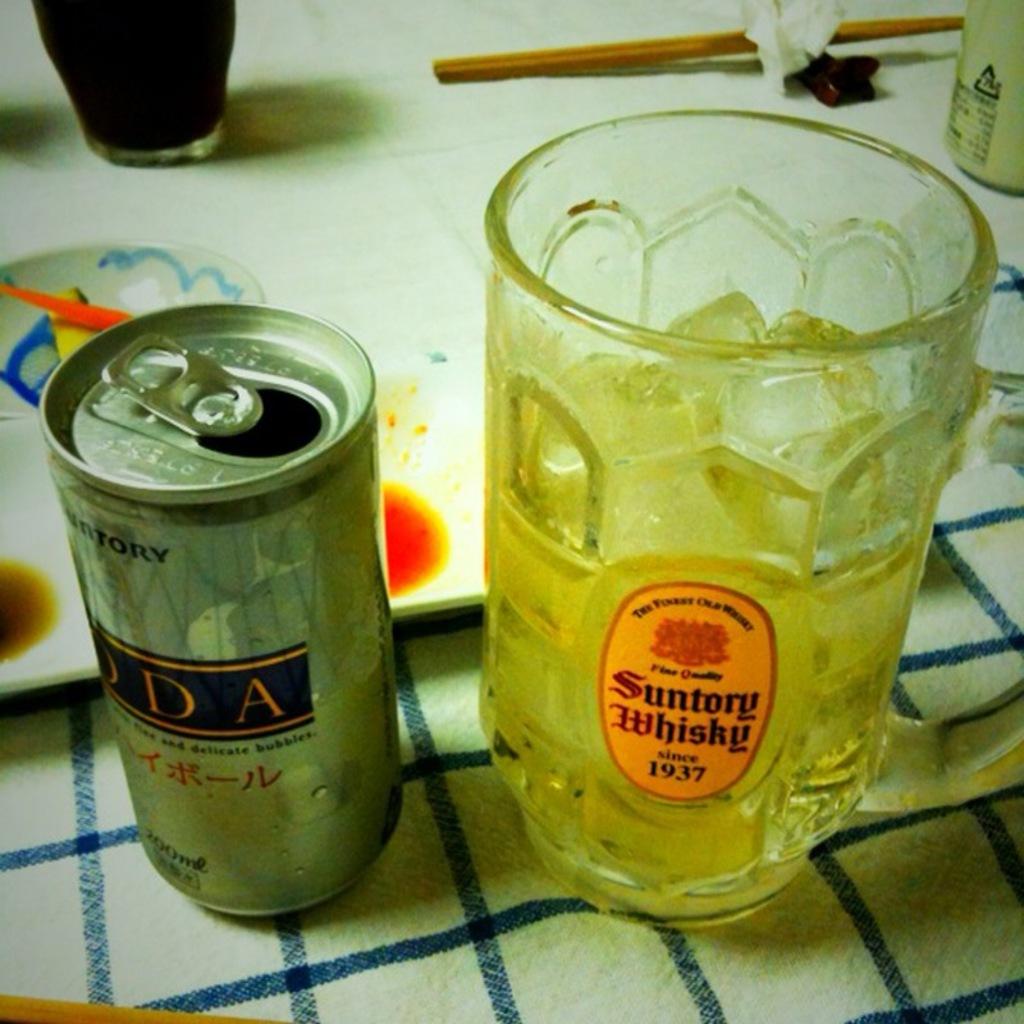What brand of whiskey is on the oval glass cup sticker?
Provide a succinct answer. Suntory. What year is the whiskey?
Provide a short and direct response. 1937. 